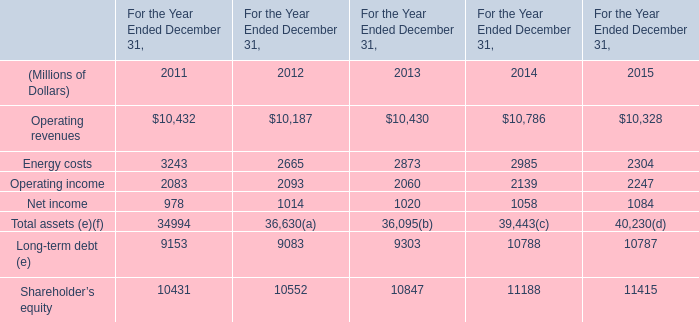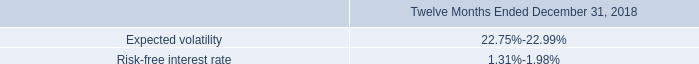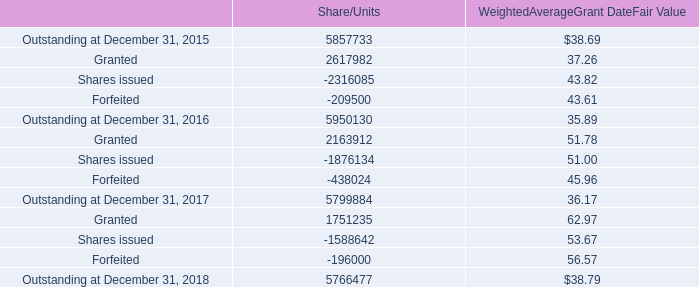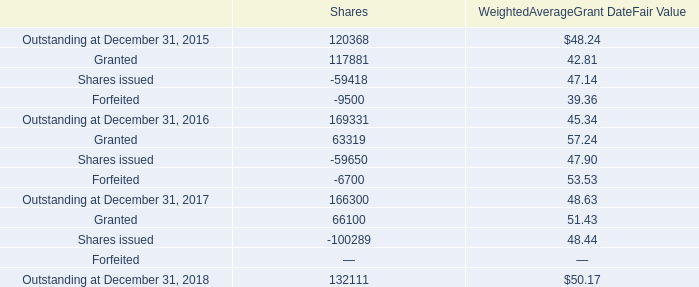What's the sum of Net income of For the Year Ended December 31, 2013, and Shares issued of Shares ? 
Computations: (1020.0 + 100289.0)
Answer: 101309.0. 